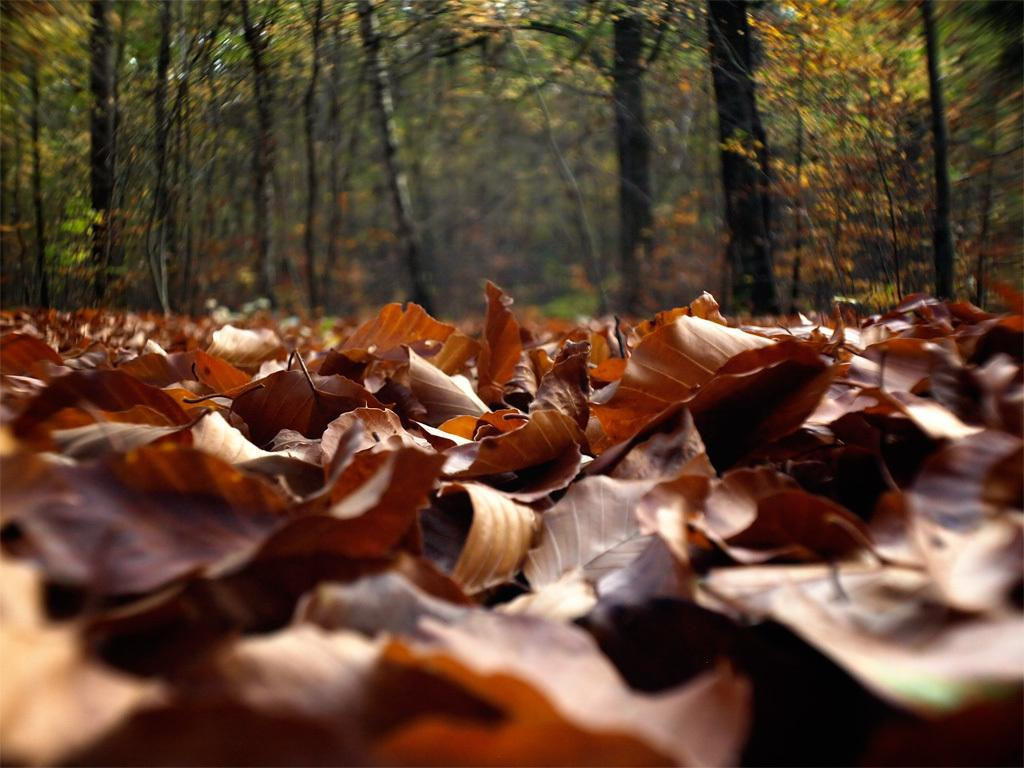What is present in the foreground of the image? There are dry leaves in the foreground of the image. What can be seen in the background of the image? There are trees in the background of the image. What is the limit of the crow's flight in the image? There is no crow present in the image, so it is not possible to determine the limit of its flight. 